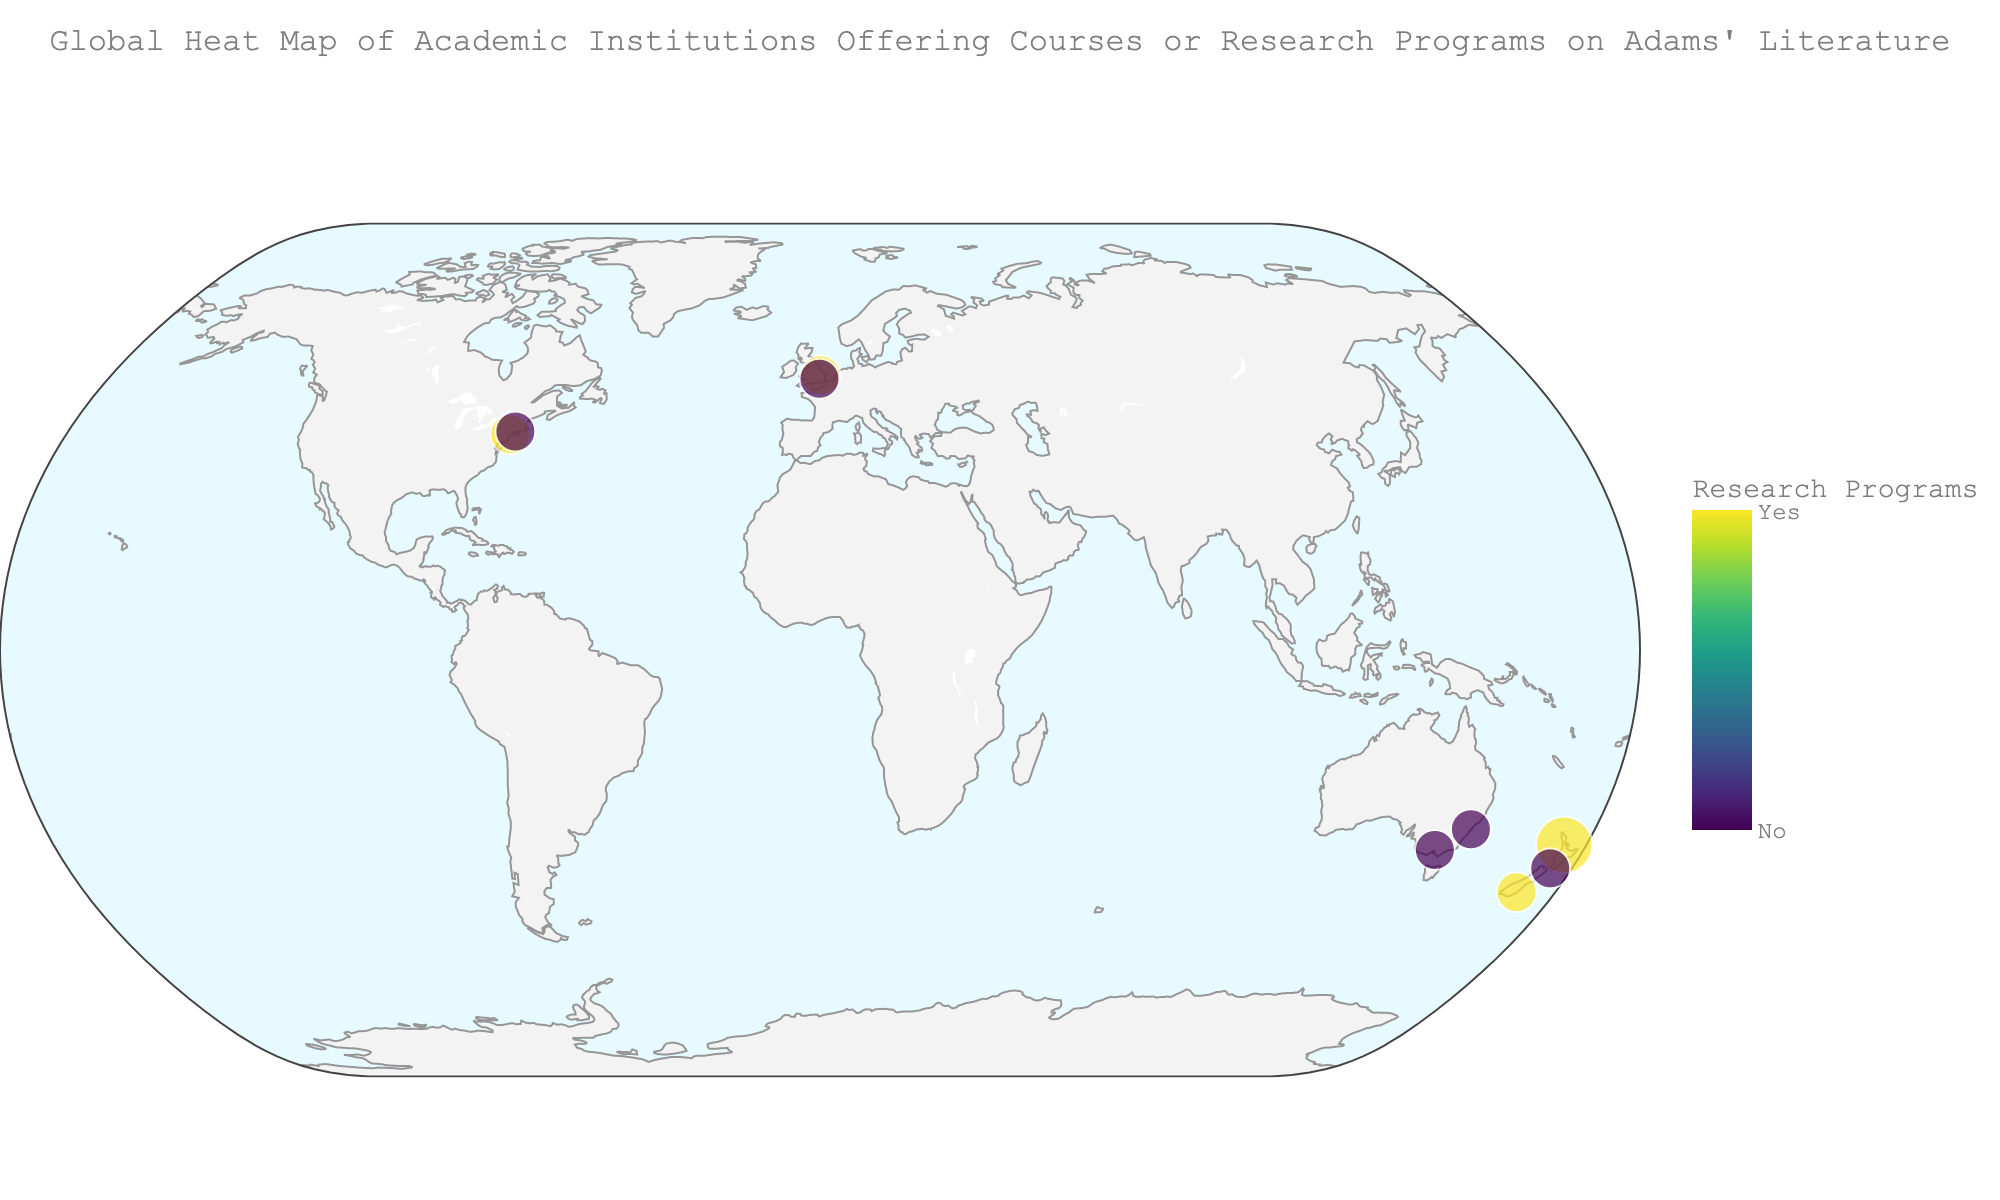What is the title of the geographical plot? The title of the plot is usually placed at the top and is written as a descriptive phrase.
Answer: Global Heat Map of Academic Institutions Offering Courses or Research Programs on Adams' Literature Which university is the southernmost on the map? The southernmost point is identified by looking at the lowest latitude value. On the plot, the University of Otago has the lowest latitude at -45.8644.
Answer: University of Otago How many institutions are offering both courses and research programs on Arthur Henry Adams' literature? By checking the color and size indicators for each point on the map, we look for institutions with both markers. There are 3 such institutions: University of Auckland, University of Otago, and Columbia University.
Answer: 3 Which country has the highest density of academic institutions researching Arthur Henry Adams' literature? By examining the distribution of colored points on the map, particularly those indicating research programs, we see that New Zealand has three institutions: University of Auckland, Victoria University of Wellington, and University of Otago.
Answer: New Zealand How many institutions in the United States offer courses on Adams' literature? Looking at institutions located in the U.S. (identified by geographic location) and counting those with a size indicator, which reflects the number of courses, we find Columbia University and Yale University.
Answer: 2 Which institution is located closest to the equator and offers courses on Adams' literature? The equator is at 0 degrees latitude, so we look for the point closest to zero with a non-zero size. University of Sydney, located at latitude -33.8885, offers courses.
Answer: University of Sydney What is the ratio of institutions offering research programs to those offering courses in Australia? Australia has three institutions: University of Sydney, Australian National University, and University of Melbourne. University of Sydney and University of Melbourne offer courses, while Australian National University offers research programs. The ratio is 1:2.
Answer: 1:2 Which institution in the UK offers both courses and research programs on Adams' literature? In the UK, Cambridge University, Oxford University, and University College London are marked. Cambridge is the one offering both courses and research programs.
Answer: University of Cambridge Compare the number of institutions offering research programs between the U.S. and New Zealand. In the U.S., Columbia University and Harvard University offer research programs (2). In New Zealand, University of Auckland and University of Otago offer research programs (2). So both have an equal number.
Answer: Equal (2 each) Which institution in New Zealand provides the lowest number of courses on Adams' literature? Comparing the points within New Zealand, Victoria University of Wellington offers the fewest courses with just 1.
Answer: Victoria University of Wellington 